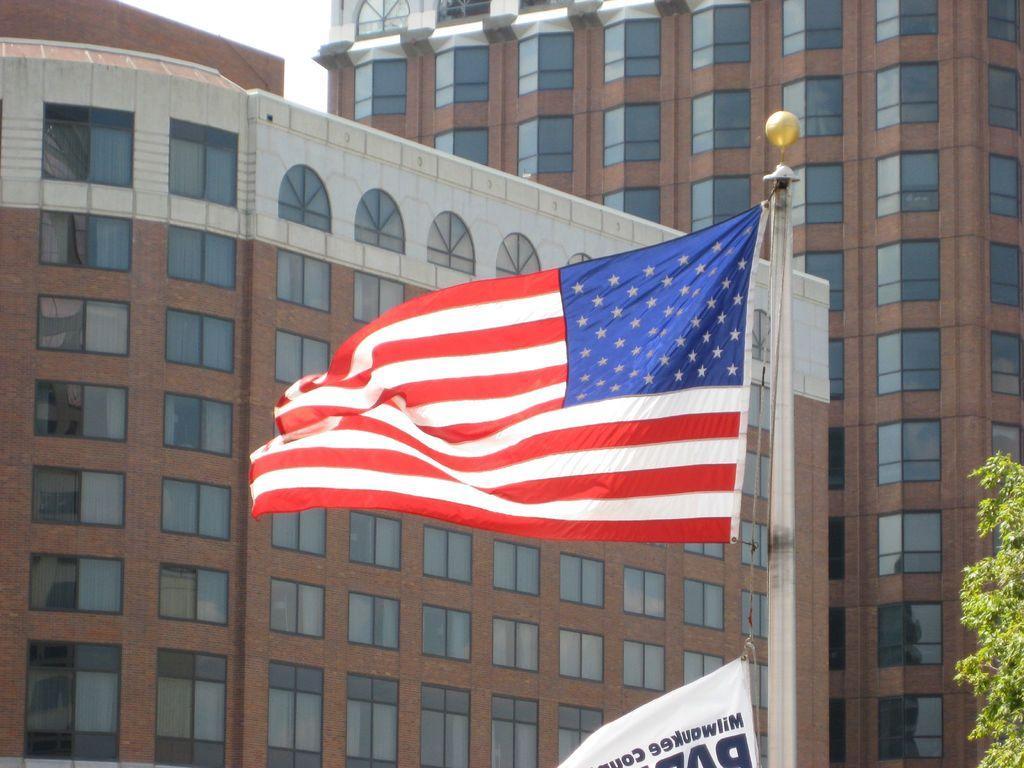Describe this image in one or two sentences. In this image in the front there are flags. On the right side there are leaves and in the background there are buildings. 